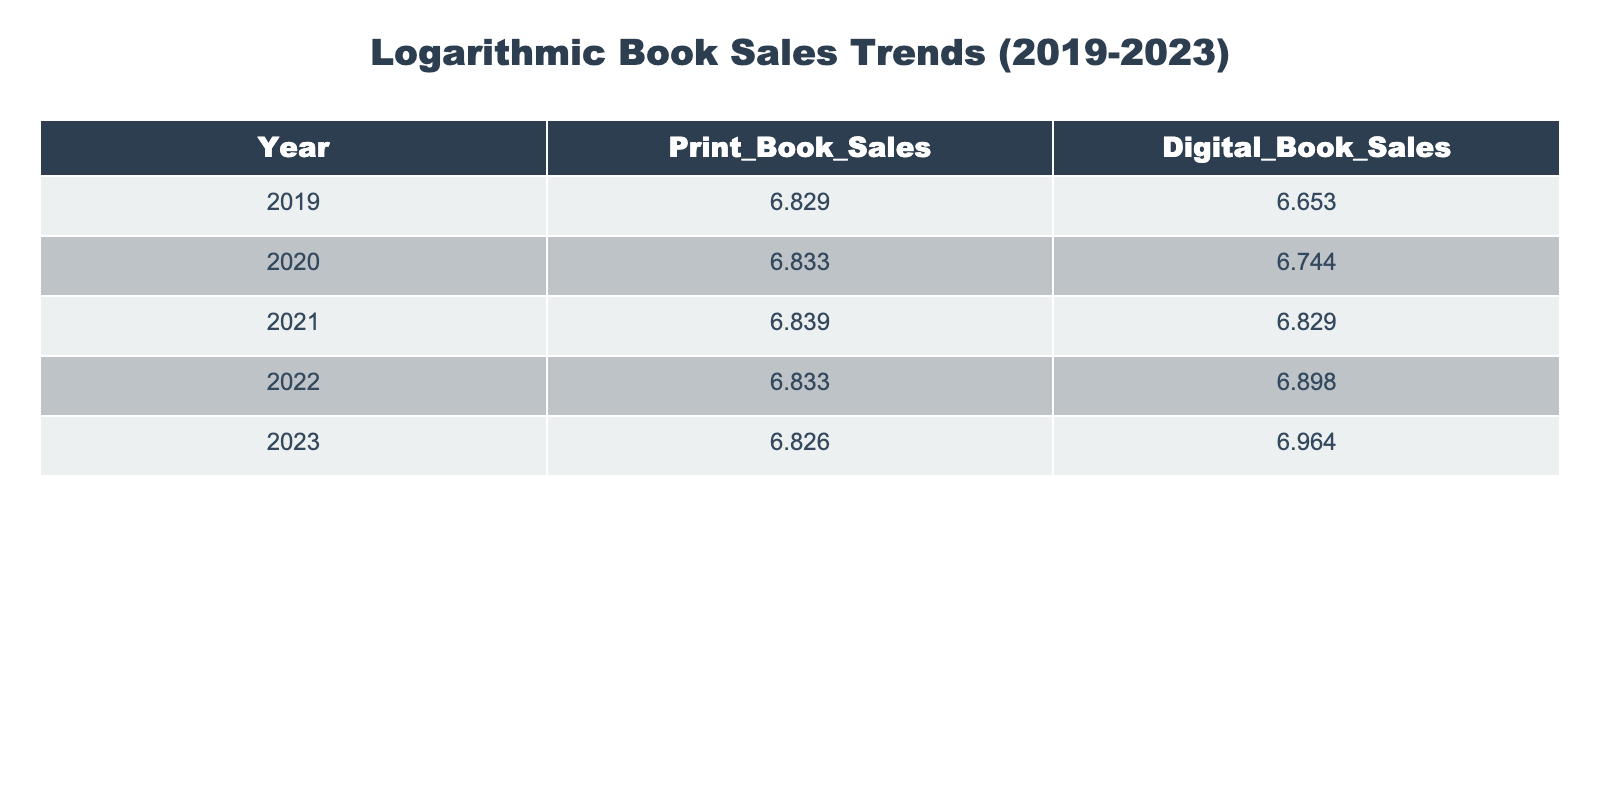What were the print book sales in 2022? In the table, the row for the year 2022 shows the value for Print_Book_Sales as 6.835.
Answer: 6.835 What were the digital book sales in 2021? Looking at the year 2021 in the table, the value for Digital_Book_Sales is 6.829.
Answer: 6.829 What is the difference in print book sales between 2019 and 2023? To find the difference, we subtract the Print_Book_Sales in 2023 (6.826) from the sales in 2019 (6.828): 6.828 - 6.826 = 0.002.
Answer: 0.002 Is there an increase in digital book sales from 2020 to 2023? By comparing the values for Digital_Book_Sales in 2020 (6.744) and in 2023 (6.964), we find that 6.964 is greater than 6.744, confirming that there is an increase.
Answer: Yes What was the average digital book sales over the five years? To compute the average, we sum the digital book sales values: 6.653 + 6.744 + 6.829 + 6.897 + 6.964 = 33.187. Dividing by 5 gives us 33.187/5 = 6.6374.
Answer: 6.6374 Which year had the highest digital book sales? A quick review of the Digital_Book_Sales column reveals that the highest value, 6.964, occurs in the year 2023.
Answer: 2023 What was the change in print book sales from 2019 to 2022? We subtract the Print_Book_Sales for 2022 (6.835) from 2019 (6.828): 6.828 - 6.835 = -0.007, indicating a decline.
Answer: -0.007 Did print book sales decline in 2023 compared to previous years? By examining the values, we see that sales in 2023 (6.826) are lower than the sales in 2022 (6.835), indicating a decline.
Answer: Yes 